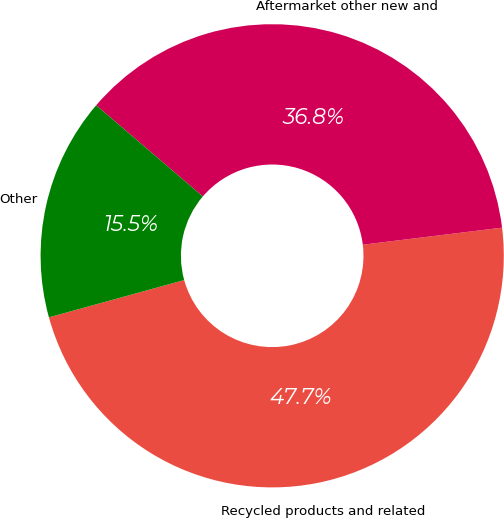Convert chart. <chart><loc_0><loc_0><loc_500><loc_500><pie_chart><fcel>Recycled products and related<fcel>Aftermarket other new and<fcel>Other<nl><fcel>47.66%<fcel>36.8%<fcel>15.54%<nl></chart> 